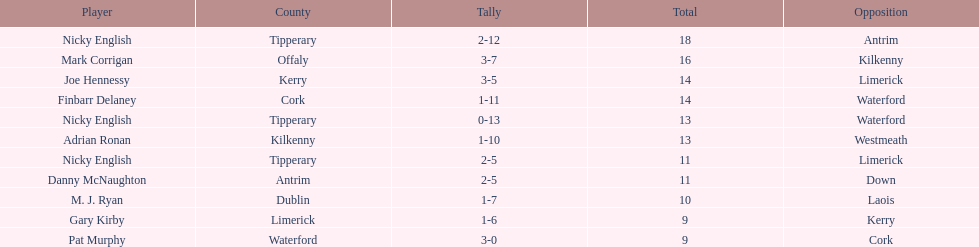How many times was waterford the opposition? 2. 